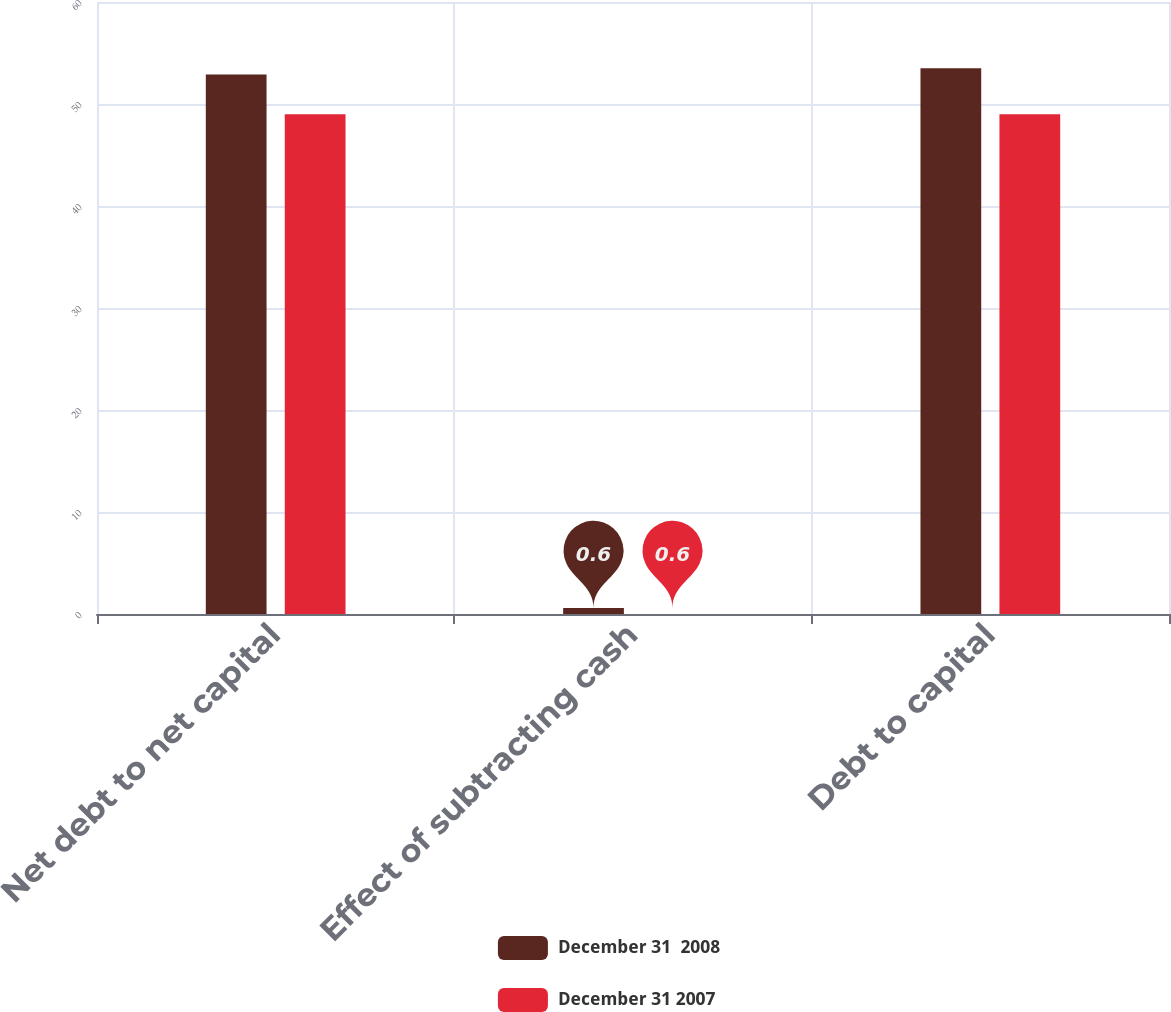Convert chart to OTSL. <chart><loc_0><loc_0><loc_500><loc_500><stacked_bar_chart><ecel><fcel>Net debt to net capital<fcel>Effect of subtracting cash<fcel>Debt to capital<nl><fcel>December 31  2008<fcel>52.9<fcel>0.6<fcel>53.5<nl><fcel>December 31 2007<fcel>49<fcel>0<fcel>49<nl></chart> 